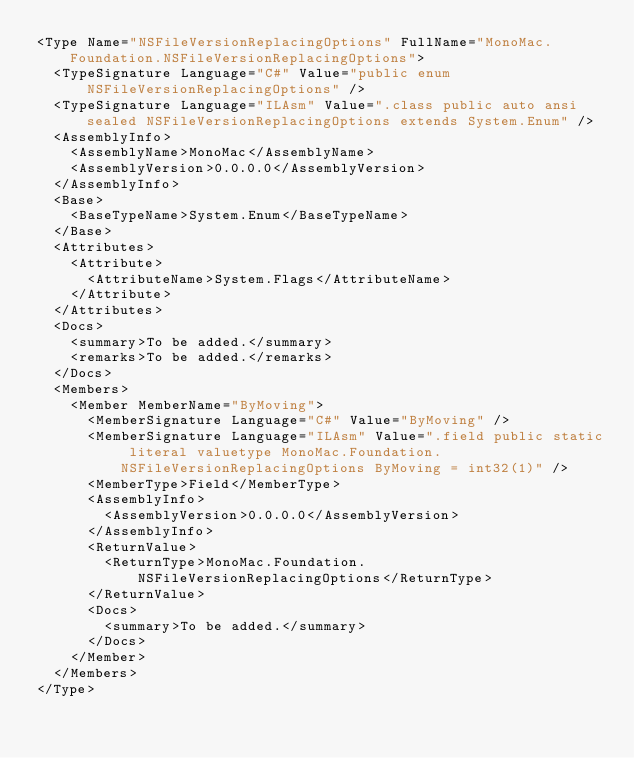<code> <loc_0><loc_0><loc_500><loc_500><_XML_><Type Name="NSFileVersionReplacingOptions" FullName="MonoMac.Foundation.NSFileVersionReplacingOptions">
  <TypeSignature Language="C#" Value="public enum NSFileVersionReplacingOptions" />
  <TypeSignature Language="ILAsm" Value=".class public auto ansi sealed NSFileVersionReplacingOptions extends System.Enum" />
  <AssemblyInfo>
    <AssemblyName>MonoMac</AssemblyName>
    <AssemblyVersion>0.0.0.0</AssemblyVersion>
  </AssemblyInfo>
  <Base>
    <BaseTypeName>System.Enum</BaseTypeName>
  </Base>
  <Attributes>
    <Attribute>
      <AttributeName>System.Flags</AttributeName>
    </Attribute>
  </Attributes>
  <Docs>
    <summary>To be added.</summary>
    <remarks>To be added.</remarks>
  </Docs>
  <Members>
    <Member MemberName="ByMoving">
      <MemberSignature Language="C#" Value="ByMoving" />
      <MemberSignature Language="ILAsm" Value=".field public static literal valuetype MonoMac.Foundation.NSFileVersionReplacingOptions ByMoving = int32(1)" />
      <MemberType>Field</MemberType>
      <AssemblyInfo>
        <AssemblyVersion>0.0.0.0</AssemblyVersion>
      </AssemblyInfo>
      <ReturnValue>
        <ReturnType>MonoMac.Foundation.NSFileVersionReplacingOptions</ReturnType>
      </ReturnValue>
      <Docs>
        <summary>To be added.</summary>
      </Docs>
    </Member>
  </Members>
</Type>
</code> 